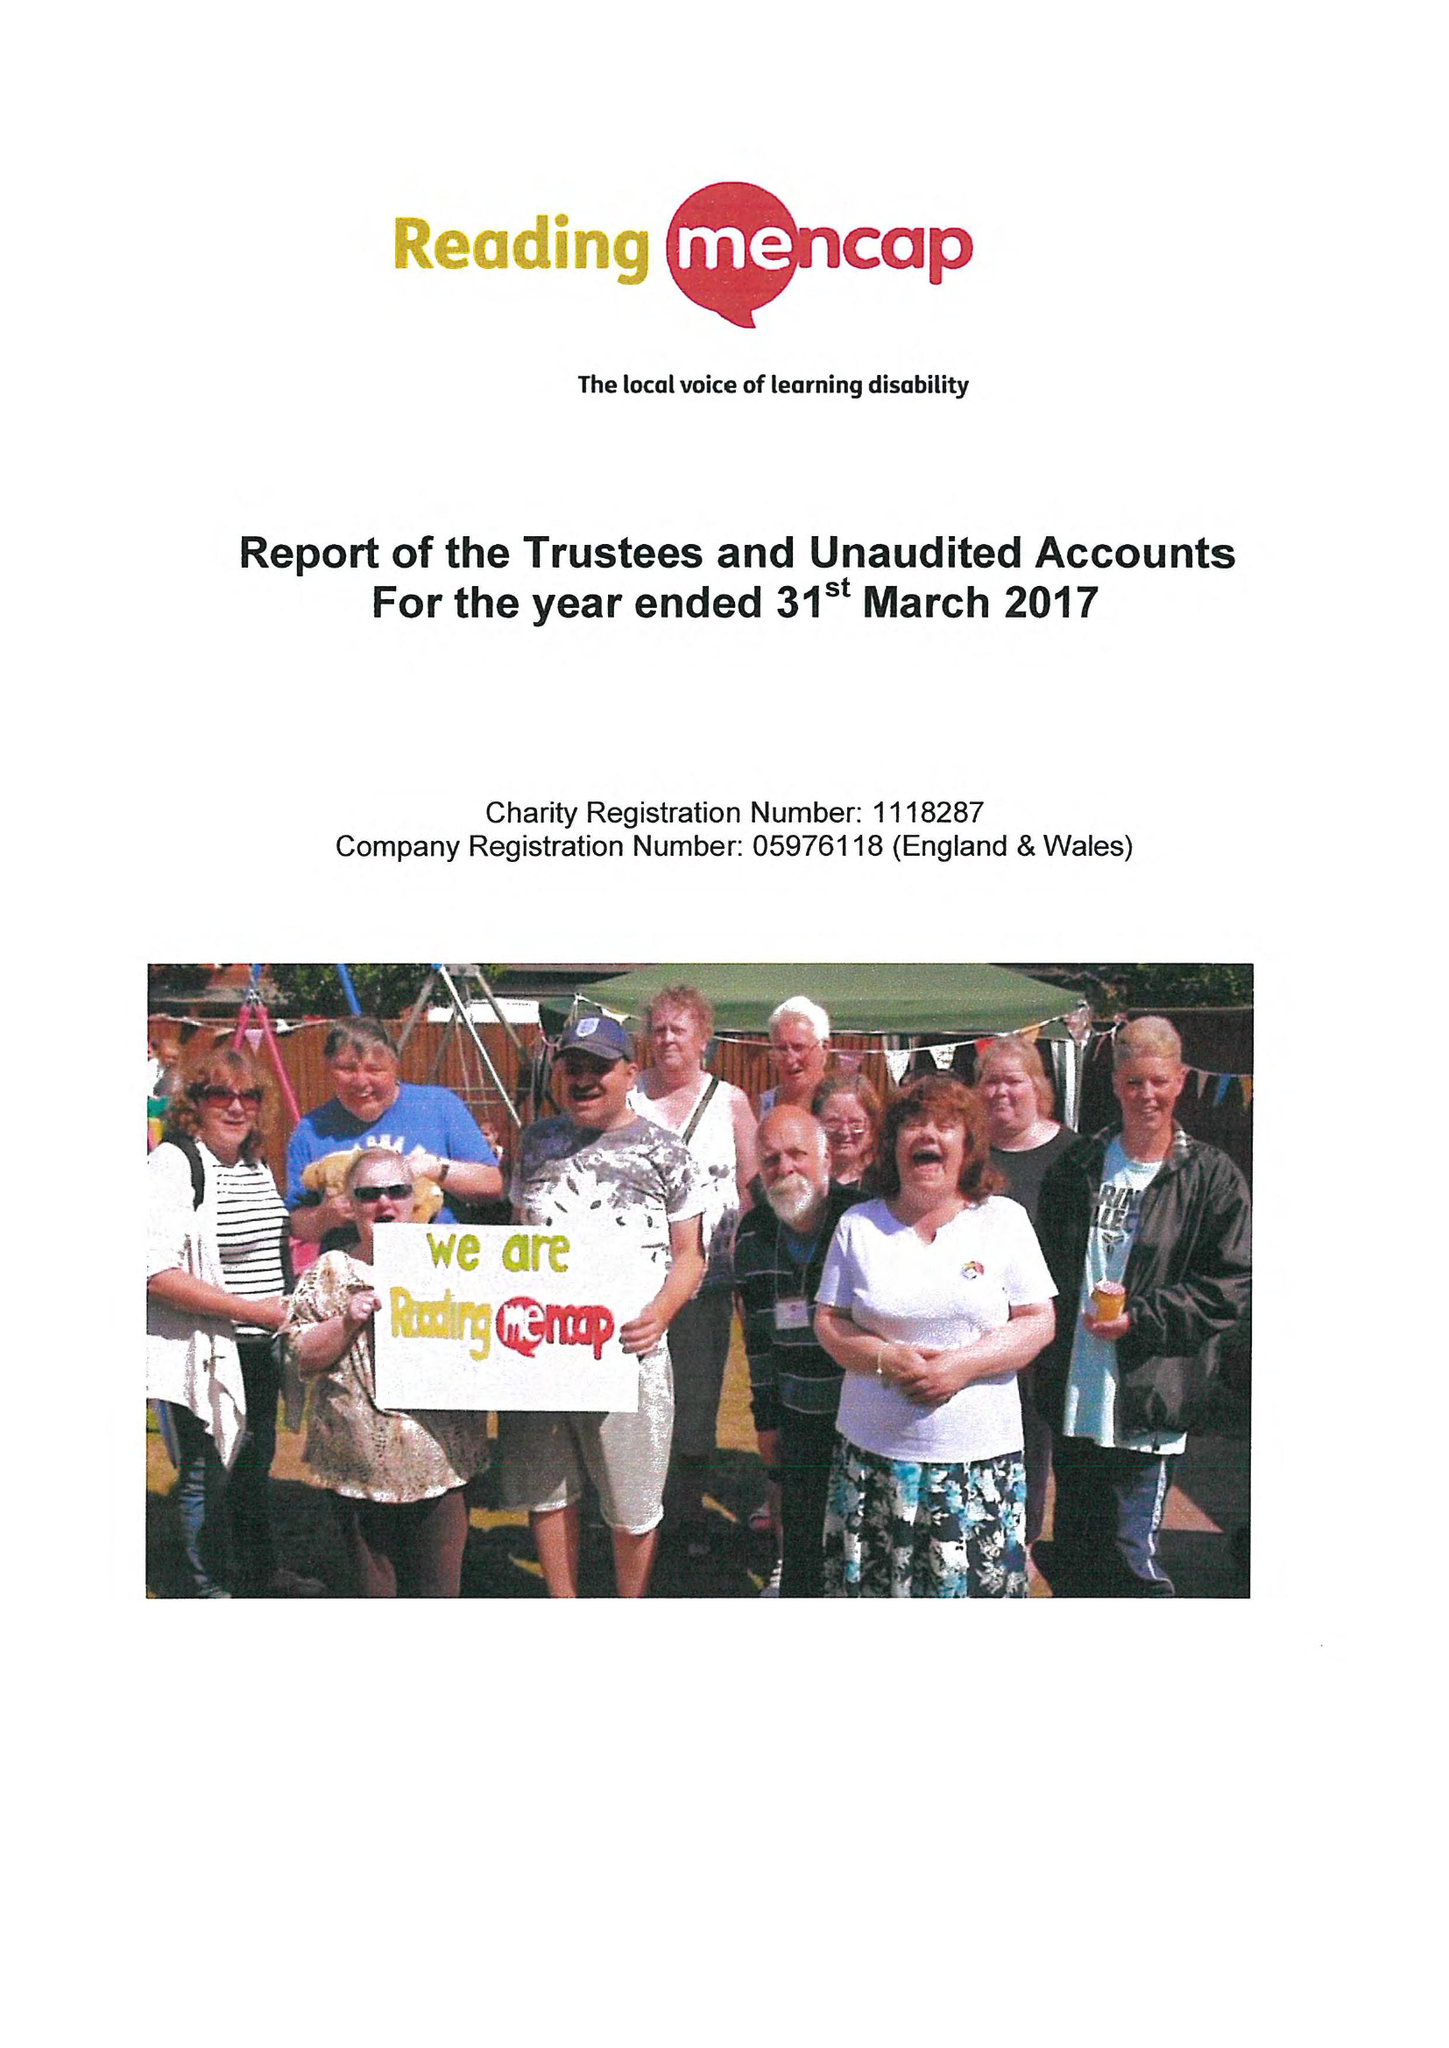What is the value for the report_date?
Answer the question using a single word or phrase. 2017-03-31 